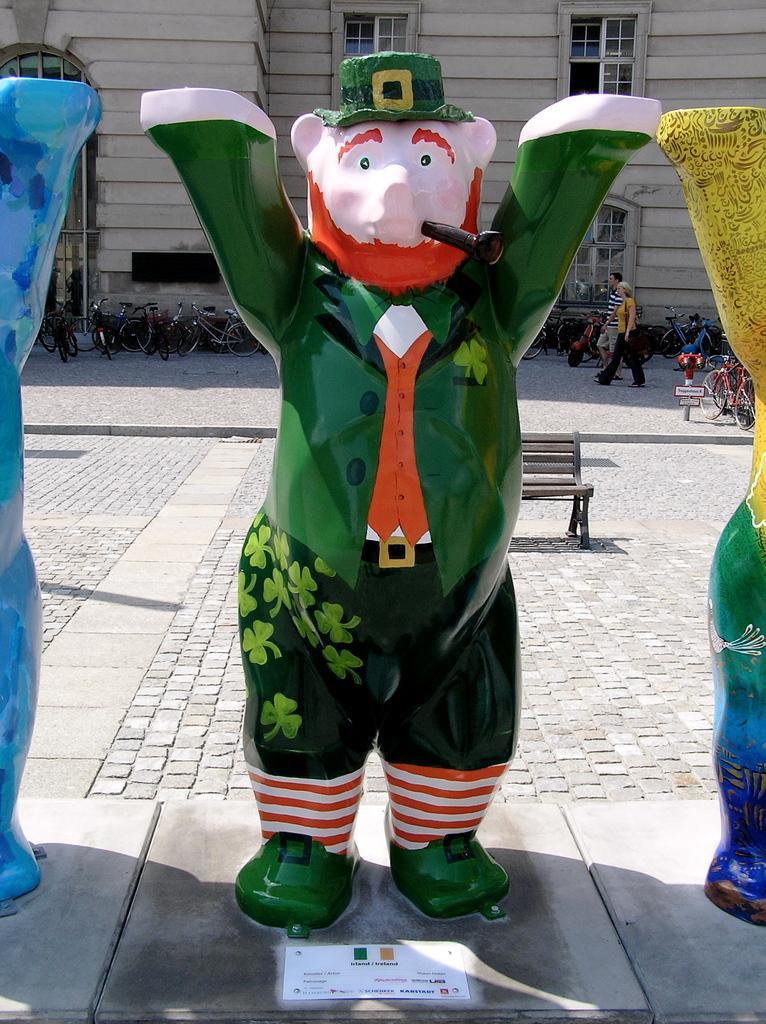Please provide a concise description of this image. In this image on the foreground there are three statues. In the background there is building, bicycles, path, bench, pole are there. Two persons are walking. On the ground there are cobblestones. 